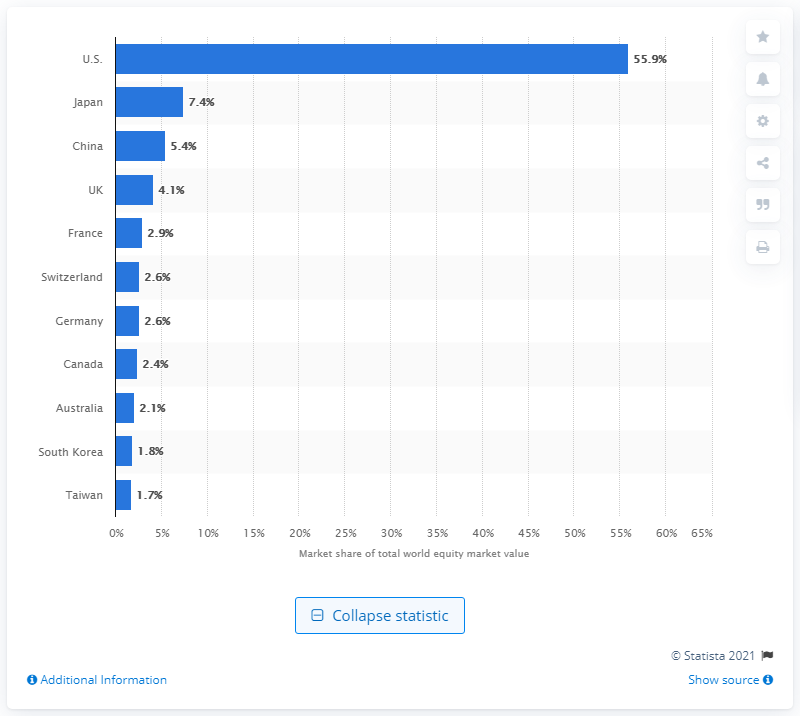Identify some key points in this picture. In 2021, the United States held 55.9% of the world's stocks. Japan is the second largest country by stock market share. China was the second largest country in terms of stock market share. 